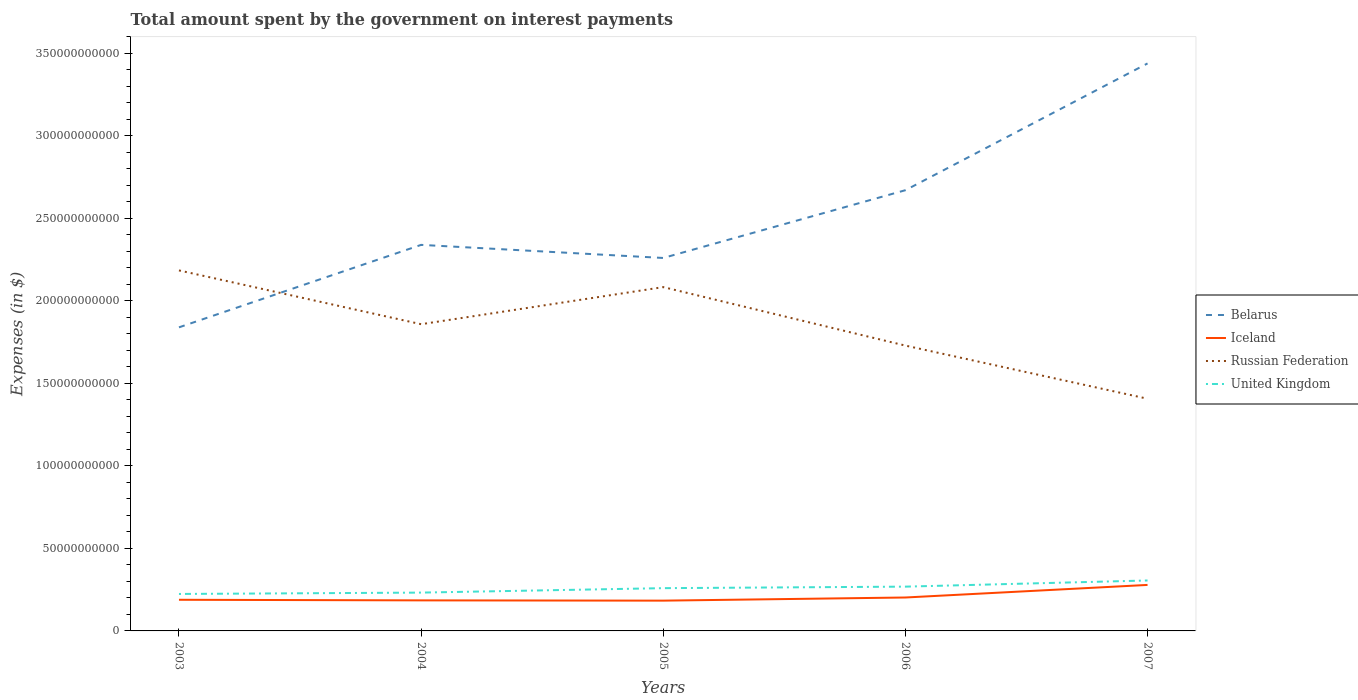Does the line corresponding to United Kingdom intersect with the line corresponding to Russian Federation?
Offer a terse response. No. Is the number of lines equal to the number of legend labels?
Provide a short and direct response. Yes. Across all years, what is the maximum amount spent on interest payments by the government in Belarus?
Ensure brevity in your answer.  1.84e+11. In which year was the amount spent on interest payments by the government in United Kingdom maximum?
Your answer should be very brief. 2003. What is the total amount spent on interest payments by the government in Russian Federation in the graph?
Offer a very short reply. 7.78e+1. What is the difference between the highest and the second highest amount spent on interest payments by the government in Iceland?
Provide a short and direct response. 9.52e+09. What is the difference between the highest and the lowest amount spent on interest payments by the government in United Kingdom?
Ensure brevity in your answer.  3. Is the amount spent on interest payments by the government in Belarus strictly greater than the amount spent on interest payments by the government in Iceland over the years?
Offer a terse response. No. How many lines are there?
Provide a succinct answer. 4. What is the difference between two consecutive major ticks on the Y-axis?
Give a very brief answer. 5.00e+1. Does the graph contain any zero values?
Give a very brief answer. No. How many legend labels are there?
Offer a terse response. 4. What is the title of the graph?
Offer a terse response. Total amount spent by the government on interest payments. What is the label or title of the Y-axis?
Give a very brief answer. Expenses (in $). What is the Expenses (in $) in Belarus in 2003?
Provide a succinct answer. 1.84e+11. What is the Expenses (in $) of Iceland in 2003?
Keep it short and to the point. 1.89e+1. What is the Expenses (in $) in Russian Federation in 2003?
Your response must be concise. 2.18e+11. What is the Expenses (in $) in United Kingdom in 2003?
Your response must be concise. 2.24e+1. What is the Expenses (in $) of Belarus in 2004?
Your answer should be very brief. 2.34e+11. What is the Expenses (in $) in Iceland in 2004?
Provide a succinct answer. 1.85e+1. What is the Expenses (in $) of Russian Federation in 2004?
Offer a very short reply. 1.86e+11. What is the Expenses (in $) of United Kingdom in 2004?
Make the answer very short. 2.32e+1. What is the Expenses (in $) in Belarus in 2005?
Offer a terse response. 2.26e+11. What is the Expenses (in $) in Iceland in 2005?
Ensure brevity in your answer.  1.84e+1. What is the Expenses (in $) in Russian Federation in 2005?
Your answer should be very brief. 2.08e+11. What is the Expenses (in $) of United Kingdom in 2005?
Provide a succinct answer. 2.59e+1. What is the Expenses (in $) in Belarus in 2006?
Make the answer very short. 2.67e+11. What is the Expenses (in $) in Iceland in 2006?
Ensure brevity in your answer.  2.03e+1. What is the Expenses (in $) of Russian Federation in 2006?
Ensure brevity in your answer.  1.73e+11. What is the Expenses (in $) in United Kingdom in 2006?
Provide a succinct answer. 2.68e+1. What is the Expenses (in $) of Belarus in 2007?
Ensure brevity in your answer.  3.44e+11. What is the Expenses (in $) in Iceland in 2007?
Give a very brief answer. 2.79e+1. What is the Expenses (in $) of Russian Federation in 2007?
Keep it short and to the point. 1.41e+11. What is the Expenses (in $) in United Kingdom in 2007?
Your answer should be compact. 3.06e+1. Across all years, what is the maximum Expenses (in $) of Belarus?
Keep it short and to the point. 3.44e+11. Across all years, what is the maximum Expenses (in $) in Iceland?
Offer a terse response. 2.79e+1. Across all years, what is the maximum Expenses (in $) of Russian Federation?
Keep it short and to the point. 2.18e+11. Across all years, what is the maximum Expenses (in $) in United Kingdom?
Provide a succinct answer. 3.06e+1. Across all years, what is the minimum Expenses (in $) of Belarus?
Provide a succinct answer. 1.84e+11. Across all years, what is the minimum Expenses (in $) in Iceland?
Your response must be concise. 1.84e+1. Across all years, what is the minimum Expenses (in $) of Russian Federation?
Make the answer very short. 1.41e+11. Across all years, what is the minimum Expenses (in $) in United Kingdom?
Your response must be concise. 2.24e+1. What is the total Expenses (in $) in Belarus in the graph?
Your answer should be very brief. 1.25e+12. What is the total Expenses (in $) of Iceland in the graph?
Your answer should be very brief. 1.04e+11. What is the total Expenses (in $) in Russian Federation in the graph?
Your response must be concise. 9.26e+11. What is the total Expenses (in $) of United Kingdom in the graph?
Provide a succinct answer. 1.29e+11. What is the difference between the Expenses (in $) in Belarus in 2003 and that in 2004?
Provide a succinct answer. -5.00e+1. What is the difference between the Expenses (in $) in Iceland in 2003 and that in 2004?
Your answer should be very brief. 3.63e+08. What is the difference between the Expenses (in $) of Russian Federation in 2003 and that in 2004?
Provide a succinct answer. 3.26e+1. What is the difference between the Expenses (in $) of United Kingdom in 2003 and that in 2004?
Ensure brevity in your answer.  -8.25e+08. What is the difference between the Expenses (in $) of Belarus in 2003 and that in 2005?
Ensure brevity in your answer.  -4.20e+1. What is the difference between the Expenses (in $) of Iceland in 2003 and that in 2005?
Give a very brief answer. 5.17e+08. What is the difference between the Expenses (in $) of Russian Federation in 2003 and that in 2005?
Ensure brevity in your answer.  1.01e+1. What is the difference between the Expenses (in $) of United Kingdom in 2003 and that in 2005?
Offer a terse response. -3.52e+09. What is the difference between the Expenses (in $) in Belarus in 2003 and that in 2006?
Your response must be concise. -8.31e+1. What is the difference between the Expenses (in $) of Iceland in 2003 and that in 2006?
Offer a very short reply. -1.38e+09. What is the difference between the Expenses (in $) in Russian Federation in 2003 and that in 2006?
Provide a succinct answer. 4.56e+1. What is the difference between the Expenses (in $) of United Kingdom in 2003 and that in 2006?
Keep it short and to the point. -4.44e+09. What is the difference between the Expenses (in $) in Belarus in 2003 and that in 2007?
Your answer should be compact. -1.60e+11. What is the difference between the Expenses (in $) of Iceland in 2003 and that in 2007?
Your response must be concise. -9.01e+09. What is the difference between the Expenses (in $) of Russian Federation in 2003 and that in 2007?
Your response must be concise. 7.78e+1. What is the difference between the Expenses (in $) in United Kingdom in 2003 and that in 2007?
Offer a terse response. -8.17e+09. What is the difference between the Expenses (in $) in Belarus in 2004 and that in 2005?
Give a very brief answer. 7.93e+09. What is the difference between the Expenses (in $) in Iceland in 2004 and that in 2005?
Offer a terse response. 1.53e+08. What is the difference between the Expenses (in $) of Russian Federation in 2004 and that in 2005?
Give a very brief answer. -2.25e+1. What is the difference between the Expenses (in $) in United Kingdom in 2004 and that in 2005?
Keep it short and to the point. -2.69e+09. What is the difference between the Expenses (in $) in Belarus in 2004 and that in 2006?
Offer a terse response. -3.31e+1. What is the difference between the Expenses (in $) of Iceland in 2004 and that in 2006?
Give a very brief answer. -1.74e+09. What is the difference between the Expenses (in $) of Russian Federation in 2004 and that in 2006?
Offer a very short reply. 1.30e+1. What is the difference between the Expenses (in $) of United Kingdom in 2004 and that in 2006?
Provide a short and direct response. -3.61e+09. What is the difference between the Expenses (in $) of Belarus in 2004 and that in 2007?
Give a very brief answer. -1.10e+11. What is the difference between the Expenses (in $) in Iceland in 2004 and that in 2007?
Offer a terse response. -9.37e+09. What is the difference between the Expenses (in $) in Russian Federation in 2004 and that in 2007?
Give a very brief answer. 4.52e+1. What is the difference between the Expenses (in $) in United Kingdom in 2004 and that in 2007?
Offer a very short reply. -7.35e+09. What is the difference between the Expenses (in $) in Belarus in 2005 and that in 2006?
Keep it short and to the point. -4.11e+1. What is the difference between the Expenses (in $) of Iceland in 2005 and that in 2006?
Ensure brevity in your answer.  -1.90e+09. What is the difference between the Expenses (in $) of Russian Federation in 2005 and that in 2006?
Your response must be concise. 3.54e+1. What is the difference between the Expenses (in $) in United Kingdom in 2005 and that in 2006?
Offer a very short reply. -9.20e+08. What is the difference between the Expenses (in $) of Belarus in 2005 and that in 2007?
Offer a terse response. -1.18e+11. What is the difference between the Expenses (in $) of Iceland in 2005 and that in 2007?
Provide a succinct answer. -9.52e+09. What is the difference between the Expenses (in $) in Russian Federation in 2005 and that in 2007?
Your answer should be compact. 6.76e+1. What is the difference between the Expenses (in $) in United Kingdom in 2005 and that in 2007?
Provide a short and direct response. -4.65e+09. What is the difference between the Expenses (in $) of Belarus in 2006 and that in 2007?
Ensure brevity in your answer.  -7.68e+1. What is the difference between the Expenses (in $) in Iceland in 2006 and that in 2007?
Keep it short and to the point. -7.62e+09. What is the difference between the Expenses (in $) of Russian Federation in 2006 and that in 2007?
Offer a very short reply. 3.22e+1. What is the difference between the Expenses (in $) of United Kingdom in 2006 and that in 2007?
Ensure brevity in your answer.  -3.73e+09. What is the difference between the Expenses (in $) of Belarus in 2003 and the Expenses (in $) of Iceland in 2004?
Make the answer very short. 1.65e+11. What is the difference between the Expenses (in $) in Belarus in 2003 and the Expenses (in $) in Russian Federation in 2004?
Make the answer very short. -1.91e+09. What is the difference between the Expenses (in $) of Belarus in 2003 and the Expenses (in $) of United Kingdom in 2004?
Provide a succinct answer. 1.61e+11. What is the difference between the Expenses (in $) of Iceland in 2003 and the Expenses (in $) of Russian Federation in 2004?
Your response must be concise. -1.67e+11. What is the difference between the Expenses (in $) of Iceland in 2003 and the Expenses (in $) of United Kingdom in 2004?
Give a very brief answer. -4.35e+09. What is the difference between the Expenses (in $) of Russian Federation in 2003 and the Expenses (in $) of United Kingdom in 2004?
Provide a succinct answer. 1.95e+11. What is the difference between the Expenses (in $) of Belarus in 2003 and the Expenses (in $) of Iceland in 2005?
Ensure brevity in your answer.  1.66e+11. What is the difference between the Expenses (in $) in Belarus in 2003 and the Expenses (in $) in Russian Federation in 2005?
Ensure brevity in your answer.  -2.44e+1. What is the difference between the Expenses (in $) of Belarus in 2003 and the Expenses (in $) of United Kingdom in 2005?
Your answer should be very brief. 1.58e+11. What is the difference between the Expenses (in $) of Iceland in 2003 and the Expenses (in $) of Russian Federation in 2005?
Make the answer very short. -1.89e+11. What is the difference between the Expenses (in $) of Iceland in 2003 and the Expenses (in $) of United Kingdom in 2005?
Keep it short and to the point. -7.05e+09. What is the difference between the Expenses (in $) of Russian Federation in 2003 and the Expenses (in $) of United Kingdom in 2005?
Provide a succinct answer. 1.93e+11. What is the difference between the Expenses (in $) in Belarus in 2003 and the Expenses (in $) in Iceland in 2006?
Your answer should be compact. 1.64e+11. What is the difference between the Expenses (in $) in Belarus in 2003 and the Expenses (in $) in Russian Federation in 2006?
Ensure brevity in your answer.  1.11e+1. What is the difference between the Expenses (in $) of Belarus in 2003 and the Expenses (in $) of United Kingdom in 2006?
Ensure brevity in your answer.  1.57e+11. What is the difference between the Expenses (in $) of Iceland in 2003 and the Expenses (in $) of Russian Federation in 2006?
Your response must be concise. -1.54e+11. What is the difference between the Expenses (in $) of Iceland in 2003 and the Expenses (in $) of United Kingdom in 2006?
Provide a short and direct response. -7.97e+09. What is the difference between the Expenses (in $) of Russian Federation in 2003 and the Expenses (in $) of United Kingdom in 2006?
Your answer should be compact. 1.92e+11. What is the difference between the Expenses (in $) in Belarus in 2003 and the Expenses (in $) in Iceland in 2007?
Offer a terse response. 1.56e+11. What is the difference between the Expenses (in $) of Belarus in 2003 and the Expenses (in $) of Russian Federation in 2007?
Keep it short and to the point. 4.33e+1. What is the difference between the Expenses (in $) of Belarus in 2003 and the Expenses (in $) of United Kingdom in 2007?
Offer a terse response. 1.53e+11. What is the difference between the Expenses (in $) in Iceland in 2003 and the Expenses (in $) in Russian Federation in 2007?
Offer a very short reply. -1.22e+11. What is the difference between the Expenses (in $) in Iceland in 2003 and the Expenses (in $) in United Kingdom in 2007?
Your answer should be compact. -1.17e+1. What is the difference between the Expenses (in $) of Russian Federation in 2003 and the Expenses (in $) of United Kingdom in 2007?
Ensure brevity in your answer.  1.88e+11. What is the difference between the Expenses (in $) of Belarus in 2004 and the Expenses (in $) of Iceland in 2005?
Your answer should be very brief. 2.16e+11. What is the difference between the Expenses (in $) in Belarus in 2004 and the Expenses (in $) in Russian Federation in 2005?
Give a very brief answer. 2.56e+1. What is the difference between the Expenses (in $) of Belarus in 2004 and the Expenses (in $) of United Kingdom in 2005?
Ensure brevity in your answer.  2.08e+11. What is the difference between the Expenses (in $) of Iceland in 2004 and the Expenses (in $) of Russian Federation in 2005?
Offer a terse response. -1.90e+11. What is the difference between the Expenses (in $) of Iceland in 2004 and the Expenses (in $) of United Kingdom in 2005?
Your answer should be compact. -7.41e+09. What is the difference between the Expenses (in $) of Russian Federation in 2004 and the Expenses (in $) of United Kingdom in 2005?
Your answer should be compact. 1.60e+11. What is the difference between the Expenses (in $) of Belarus in 2004 and the Expenses (in $) of Iceland in 2006?
Provide a succinct answer. 2.14e+11. What is the difference between the Expenses (in $) in Belarus in 2004 and the Expenses (in $) in Russian Federation in 2006?
Make the answer very short. 6.10e+1. What is the difference between the Expenses (in $) in Belarus in 2004 and the Expenses (in $) in United Kingdom in 2006?
Your answer should be compact. 2.07e+11. What is the difference between the Expenses (in $) of Iceland in 2004 and the Expenses (in $) of Russian Federation in 2006?
Give a very brief answer. -1.54e+11. What is the difference between the Expenses (in $) in Iceland in 2004 and the Expenses (in $) in United Kingdom in 2006?
Ensure brevity in your answer.  -8.33e+09. What is the difference between the Expenses (in $) of Russian Federation in 2004 and the Expenses (in $) of United Kingdom in 2006?
Your answer should be very brief. 1.59e+11. What is the difference between the Expenses (in $) in Belarus in 2004 and the Expenses (in $) in Iceland in 2007?
Offer a terse response. 2.06e+11. What is the difference between the Expenses (in $) of Belarus in 2004 and the Expenses (in $) of Russian Federation in 2007?
Offer a terse response. 9.32e+1. What is the difference between the Expenses (in $) of Belarus in 2004 and the Expenses (in $) of United Kingdom in 2007?
Make the answer very short. 2.03e+11. What is the difference between the Expenses (in $) of Iceland in 2004 and the Expenses (in $) of Russian Federation in 2007?
Provide a short and direct response. -1.22e+11. What is the difference between the Expenses (in $) in Iceland in 2004 and the Expenses (in $) in United Kingdom in 2007?
Give a very brief answer. -1.21e+1. What is the difference between the Expenses (in $) of Russian Federation in 2004 and the Expenses (in $) of United Kingdom in 2007?
Your answer should be very brief. 1.55e+11. What is the difference between the Expenses (in $) in Belarus in 2005 and the Expenses (in $) in Iceland in 2006?
Your answer should be very brief. 2.06e+11. What is the difference between the Expenses (in $) in Belarus in 2005 and the Expenses (in $) in Russian Federation in 2006?
Ensure brevity in your answer.  5.31e+1. What is the difference between the Expenses (in $) of Belarus in 2005 and the Expenses (in $) of United Kingdom in 2006?
Provide a short and direct response. 1.99e+11. What is the difference between the Expenses (in $) in Iceland in 2005 and the Expenses (in $) in Russian Federation in 2006?
Make the answer very short. -1.55e+11. What is the difference between the Expenses (in $) of Iceland in 2005 and the Expenses (in $) of United Kingdom in 2006?
Keep it short and to the point. -8.48e+09. What is the difference between the Expenses (in $) in Russian Federation in 2005 and the Expenses (in $) in United Kingdom in 2006?
Your answer should be very brief. 1.82e+11. What is the difference between the Expenses (in $) of Belarus in 2005 and the Expenses (in $) of Iceland in 2007?
Ensure brevity in your answer.  1.98e+11. What is the difference between the Expenses (in $) of Belarus in 2005 and the Expenses (in $) of Russian Federation in 2007?
Offer a terse response. 8.53e+1. What is the difference between the Expenses (in $) of Belarus in 2005 and the Expenses (in $) of United Kingdom in 2007?
Provide a short and direct response. 1.95e+11. What is the difference between the Expenses (in $) in Iceland in 2005 and the Expenses (in $) in Russian Federation in 2007?
Offer a very short reply. -1.22e+11. What is the difference between the Expenses (in $) of Iceland in 2005 and the Expenses (in $) of United Kingdom in 2007?
Provide a short and direct response. -1.22e+1. What is the difference between the Expenses (in $) in Russian Federation in 2005 and the Expenses (in $) in United Kingdom in 2007?
Give a very brief answer. 1.78e+11. What is the difference between the Expenses (in $) in Belarus in 2006 and the Expenses (in $) in Iceland in 2007?
Make the answer very short. 2.39e+11. What is the difference between the Expenses (in $) in Belarus in 2006 and the Expenses (in $) in Russian Federation in 2007?
Provide a succinct answer. 1.26e+11. What is the difference between the Expenses (in $) of Belarus in 2006 and the Expenses (in $) of United Kingdom in 2007?
Provide a short and direct response. 2.36e+11. What is the difference between the Expenses (in $) in Iceland in 2006 and the Expenses (in $) in Russian Federation in 2007?
Give a very brief answer. -1.20e+11. What is the difference between the Expenses (in $) in Iceland in 2006 and the Expenses (in $) in United Kingdom in 2007?
Your answer should be very brief. -1.03e+1. What is the difference between the Expenses (in $) of Russian Federation in 2006 and the Expenses (in $) of United Kingdom in 2007?
Keep it short and to the point. 1.42e+11. What is the average Expenses (in $) of Belarus per year?
Your answer should be compact. 2.51e+11. What is the average Expenses (in $) in Iceland per year?
Give a very brief answer. 2.08e+1. What is the average Expenses (in $) of Russian Federation per year?
Your answer should be compact. 1.85e+11. What is the average Expenses (in $) of United Kingdom per year?
Make the answer very short. 2.58e+1. In the year 2003, what is the difference between the Expenses (in $) in Belarus and Expenses (in $) in Iceland?
Give a very brief answer. 1.65e+11. In the year 2003, what is the difference between the Expenses (in $) in Belarus and Expenses (in $) in Russian Federation?
Offer a very short reply. -3.45e+1. In the year 2003, what is the difference between the Expenses (in $) of Belarus and Expenses (in $) of United Kingdom?
Provide a short and direct response. 1.62e+11. In the year 2003, what is the difference between the Expenses (in $) of Iceland and Expenses (in $) of Russian Federation?
Keep it short and to the point. -2.00e+11. In the year 2003, what is the difference between the Expenses (in $) of Iceland and Expenses (in $) of United Kingdom?
Give a very brief answer. -3.53e+09. In the year 2003, what is the difference between the Expenses (in $) of Russian Federation and Expenses (in $) of United Kingdom?
Offer a very short reply. 1.96e+11. In the year 2004, what is the difference between the Expenses (in $) in Belarus and Expenses (in $) in Iceland?
Keep it short and to the point. 2.15e+11. In the year 2004, what is the difference between the Expenses (in $) of Belarus and Expenses (in $) of Russian Federation?
Keep it short and to the point. 4.81e+1. In the year 2004, what is the difference between the Expenses (in $) of Belarus and Expenses (in $) of United Kingdom?
Offer a very short reply. 2.11e+11. In the year 2004, what is the difference between the Expenses (in $) in Iceland and Expenses (in $) in Russian Federation?
Provide a short and direct response. -1.67e+11. In the year 2004, what is the difference between the Expenses (in $) of Iceland and Expenses (in $) of United Kingdom?
Offer a terse response. -4.72e+09. In the year 2004, what is the difference between the Expenses (in $) in Russian Federation and Expenses (in $) in United Kingdom?
Your response must be concise. 1.63e+11. In the year 2005, what is the difference between the Expenses (in $) of Belarus and Expenses (in $) of Iceland?
Provide a succinct answer. 2.08e+11. In the year 2005, what is the difference between the Expenses (in $) in Belarus and Expenses (in $) in Russian Federation?
Your answer should be very brief. 1.77e+1. In the year 2005, what is the difference between the Expenses (in $) in Belarus and Expenses (in $) in United Kingdom?
Your answer should be very brief. 2.00e+11. In the year 2005, what is the difference between the Expenses (in $) in Iceland and Expenses (in $) in Russian Federation?
Offer a very short reply. -1.90e+11. In the year 2005, what is the difference between the Expenses (in $) of Iceland and Expenses (in $) of United Kingdom?
Make the answer very short. -7.56e+09. In the year 2005, what is the difference between the Expenses (in $) of Russian Federation and Expenses (in $) of United Kingdom?
Offer a very short reply. 1.82e+11. In the year 2006, what is the difference between the Expenses (in $) in Belarus and Expenses (in $) in Iceland?
Keep it short and to the point. 2.47e+11. In the year 2006, what is the difference between the Expenses (in $) of Belarus and Expenses (in $) of Russian Federation?
Your response must be concise. 9.42e+1. In the year 2006, what is the difference between the Expenses (in $) in Belarus and Expenses (in $) in United Kingdom?
Offer a terse response. 2.40e+11. In the year 2006, what is the difference between the Expenses (in $) in Iceland and Expenses (in $) in Russian Federation?
Ensure brevity in your answer.  -1.53e+11. In the year 2006, what is the difference between the Expenses (in $) in Iceland and Expenses (in $) in United Kingdom?
Offer a terse response. -6.59e+09. In the year 2006, what is the difference between the Expenses (in $) of Russian Federation and Expenses (in $) of United Kingdom?
Ensure brevity in your answer.  1.46e+11. In the year 2007, what is the difference between the Expenses (in $) of Belarus and Expenses (in $) of Iceland?
Provide a succinct answer. 3.16e+11. In the year 2007, what is the difference between the Expenses (in $) of Belarus and Expenses (in $) of Russian Federation?
Offer a terse response. 2.03e+11. In the year 2007, what is the difference between the Expenses (in $) in Belarus and Expenses (in $) in United Kingdom?
Your answer should be very brief. 3.13e+11. In the year 2007, what is the difference between the Expenses (in $) of Iceland and Expenses (in $) of Russian Federation?
Your response must be concise. -1.13e+11. In the year 2007, what is the difference between the Expenses (in $) in Iceland and Expenses (in $) in United Kingdom?
Your response must be concise. -2.69e+09. In the year 2007, what is the difference between the Expenses (in $) of Russian Federation and Expenses (in $) of United Kingdom?
Provide a succinct answer. 1.10e+11. What is the ratio of the Expenses (in $) in Belarus in 2003 to that in 2004?
Give a very brief answer. 0.79. What is the ratio of the Expenses (in $) of Iceland in 2003 to that in 2004?
Ensure brevity in your answer.  1.02. What is the ratio of the Expenses (in $) in Russian Federation in 2003 to that in 2004?
Offer a very short reply. 1.18. What is the ratio of the Expenses (in $) in United Kingdom in 2003 to that in 2004?
Ensure brevity in your answer.  0.96. What is the ratio of the Expenses (in $) of Belarus in 2003 to that in 2005?
Provide a succinct answer. 0.81. What is the ratio of the Expenses (in $) in Iceland in 2003 to that in 2005?
Your response must be concise. 1.03. What is the ratio of the Expenses (in $) in Russian Federation in 2003 to that in 2005?
Give a very brief answer. 1.05. What is the ratio of the Expenses (in $) of United Kingdom in 2003 to that in 2005?
Your answer should be compact. 0.86. What is the ratio of the Expenses (in $) in Belarus in 2003 to that in 2006?
Offer a terse response. 0.69. What is the ratio of the Expenses (in $) in Iceland in 2003 to that in 2006?
Give a very brief answer. 0.93. What is the ratio of the Expenses (in $) in Russian Federation in 2003 to that in 2006?
Give a very brief answer. 1.26. What is the ratio of the Expenses (in $) of United Kingdom in 2003 to that in 2006?
Offer a terse response. 0.83. What is the ratio of the Expenses (in $) of Belarus in 2003 to that in 2007?
Give a very brief answer. 0.53. What is the ratio of the Expenses (in $) in Iceland in 2003 to that in 2007?
Provide a short and direct response. 0.68. What is the ratio of the Expenses (in $) of Russian Federation in 2003 to that in 2007?
Ensure brevity in your answer.  1.55. What is the ratio of the Expenses (in $) in United Kingdom in 2003 to that in 2007?
Provide a short and direct response. 0.73. What is the ratio of the Expenses (in $) in Belarus in 2004 to that in 2005?
Give a very brief answer. 1.04. What is the ratio of the Expenses (in $) in Iceland in 2004 to that in 2005?
Keep it short and to the point. 1.01. What is the ratio of the Expenses (in $) of Russian Federation in 2004 to that in 2005?
Give a very brief answer. 0.89. What is the ratio of the Expenses (in $) in United Kingdom in 2004 to that in 2005?
Ensure brevity in your answer.  0.9. What is the ratio of the Expenses (in $) of Belarus in 2004 to that in 2006?
Your answer should be very brief. 0.88. What is the ratio of the Expenses (in $) in Iceland in 2004 to that in 2006?
Make the answer very short. 0.91. What is the ratio of the Expenses (in $) in Russian Federation in 2004 to that in 2006?
Give a very brief answer. 1.07. What is the ratio of the Expenses (in $) of United Kingdom in 2004 to that in 2006?
Ensure brevity in your answer.  0.87. What is the ratio of the Expenses (in $) of Belarus in 2004 to that in 2007?
Provide a short and direct response. 0.68. What is the ratio of the Expenses (in $) in Iceland in 2004 to that in 2007?
Provide a short and direct response. 0.66. What is the ratio of the Expenses (in $) of Russian Federation in 2004 to that in 2007?
Offer a terse response. 1.32. What is the ratio of the Expenses (in $) of United Kingdom in 2004 to that in 2007?
Offer a terse response. 0.76. What is the ratio of the Expenses (in $) in Belarus in 2005 to that in 2006?
Give a very brief answer. 0.85. What is the ratio of the Expenses (in $) of Iceland in 2005 to that in 2006?
Keep it short and to the point. 0.91. What is the ratio of the Expenses (in $) in Russian Federation in 2005 to that in 2006?
Keep it short and to the point. 1.21. What is the ratio of the Expenses (in $) of United Kingdom in 2005 to that in 2006?
Provide a succinct answer. 0.97. What is the ratio of the Expenses (in $) in Belarus in 2005 to that in 2007?
Your response must be concise. 0.66. What is the ratio of the Expenses (in $) in Iceland in 2005 to that in 2007?
Provide a succinct answer. 0.66. What is the ratio of the Expenses (in $) of Russian Federation in 2005 to that in 2007?
Make the answer very short. 1.48. What is the ratio of the Expenses (in $) in United Kingdom in 2005 to that in 2007?
Give a very brief answer. 0.85. What is the ratio of the Expenses (in $) in Belarus in 2006 to that in 2007?
Provide a short and direct response. 0.78. What is the ratio of the Expenses (in $) of Iceland in 2006 to that in 2007?
Provide a short and direct response. 0.73. What is the ratio of the Expenses (in $) of Russian Federation in 2006 to that in 2007?
Provide a short and direct response. 1.23. What is the ratio of the Expenses (in $) of United Kingdom in 2006 to that in 2007?
Your answer should be very brief. 0.88. What is the difference between the highest and the second highest Expenses (in $) of Belarus?
Give a very brief answer. 7.68e+1. What is the difference between the highest and the second highest Expenses (in $) of Iceland?
Keep it short and to the point. 7.62e+09. What is the difference between the highest and the second highest Expenses (in $) in Russian Federation?
Your answer should be very brief. 1.01e+1. What is the difference between the highest and the second highest Expenses (in $) in United Kingdom?
Keep it short and to the point. 3.73e+09. What is the difference between the highest and the lowest Expenses (in $) of Belarus?
Your response must be concise. 1.60e+11. What is the difference between the highest and the lowest Expenses (in $) in Iceland?
Your answer should be compact. 9.52e+09. What is the difference between the highest and the lowest Expenses (in $) in Russian Federation?
Offer a terse response. 7.78e+1. What is the difference between the highest and the lowest Expenses (in $) in United Kingdom?
Your answer should be very brief. 8.17e+09. 